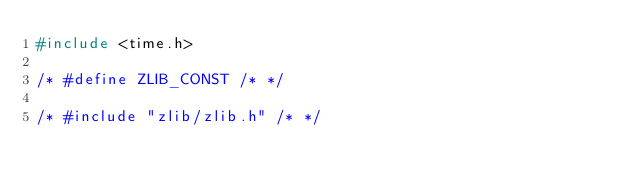Convert code to text. <code><loc_0><loc_0><loc_500><loc_500><_C_>#include <time.h>

/* #define ZLIB_CONST /* */

/* #include "zlib/zlib.h" /* */</code> 